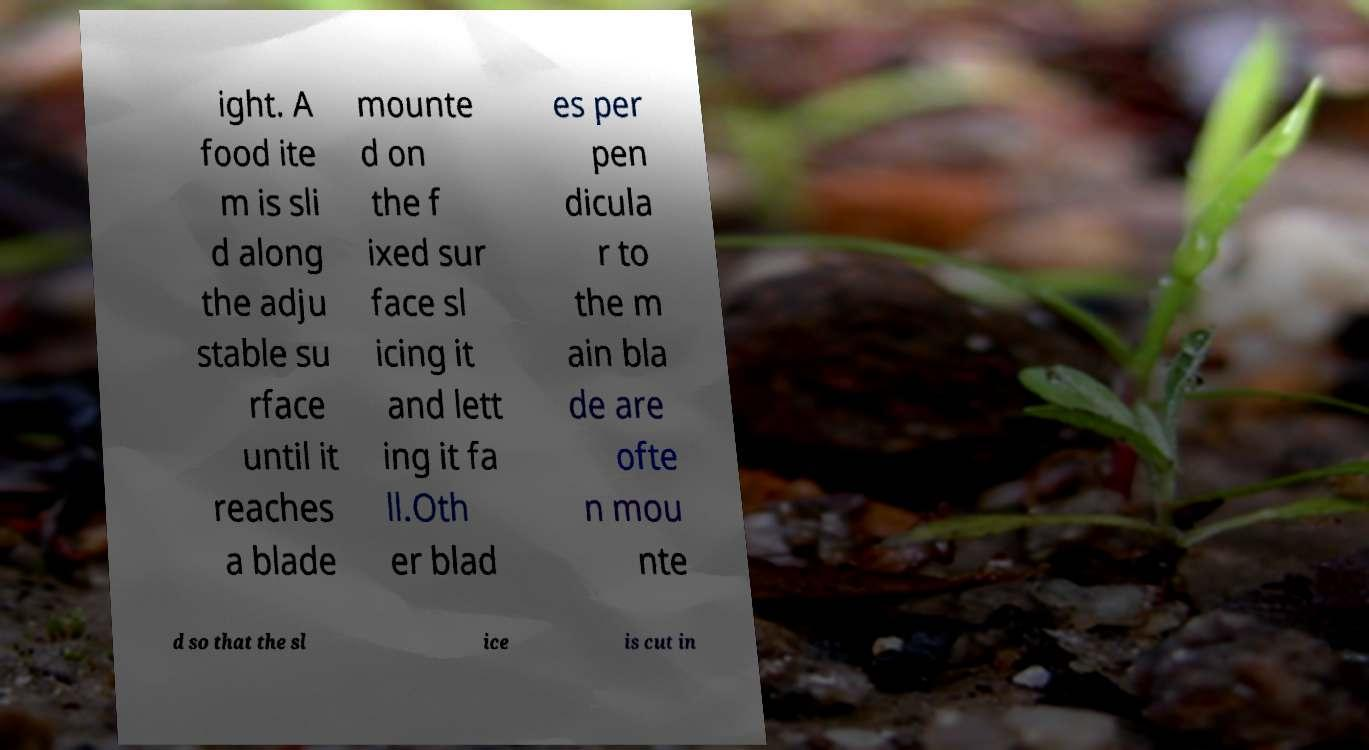There's text embedded in this image that I need extracted. Can you transcribe it verbatim? ight. A food ite m is sli d along the adju stable su rface until it reaches a blade mounte d on the f ixed sur face sl icing it and lett ing it fa ll.Oth er blad es per pen dicula r to the m ain bla de are ofte n mou nte d so that the sl ice is cut in 